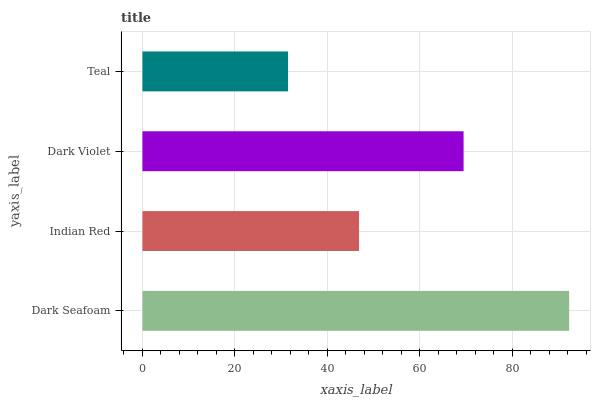Is Teal the minimum?
Answer yes or no. Yes. Is Dark Seafoam the maximum?
Answer yes or no. Yes. Is Indian Red the minimum?
Answer yes or no. No. Is Indian Red the maximum?
Answer yes or no. No. Is Dark Seafoam greater than Indian Red?
Answer yes or no. Yes. Is Indian Red less than Dark Seafoam?
Answer yes or no. Yes. Is Indian Red greater than Dark Seafoam?
Answer yes or no. No. Is Dark Seafoam less than Indian Red?
Answer yes or no. No. Is Dark Violet the high median?
Answer yes or no. Yes. Is Indian Red the low median?
Answer yes or no. Yes. Is Indian Red the high median?
Answer yes or no. No. Is Teal the low median?
Answer yes or no. No. 